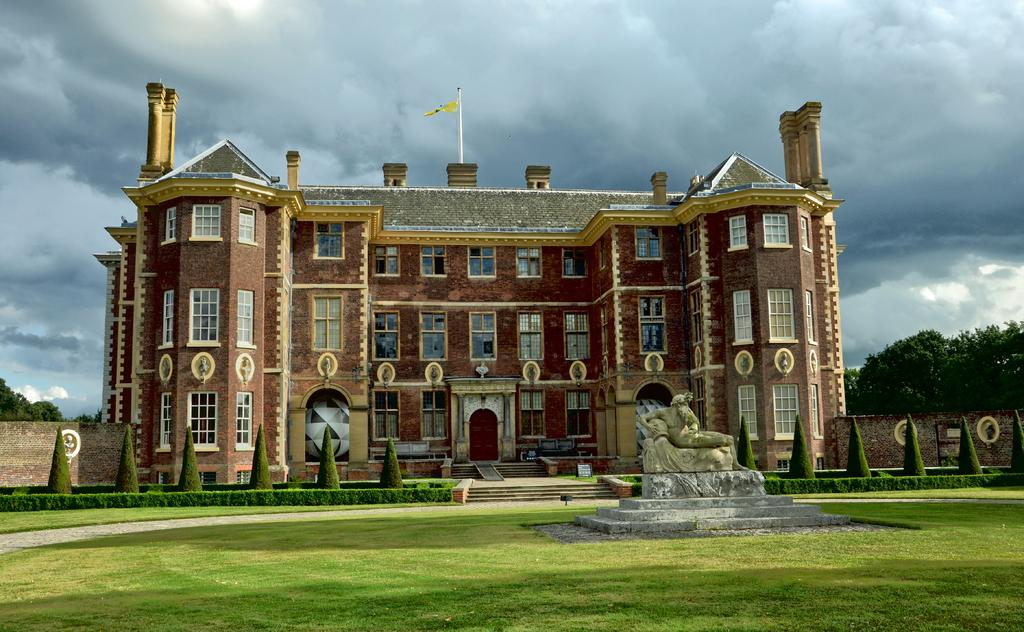What type of landscape is visible in the foreground of the image? There is grassland in the foreground of the image. What is located in the foreground of the image besides the grassland? There is a statue in the foreground of the image. What can be seen in the background of the image? There are trees, plants, a building, and a flag in the background of the image. What is visible at the top of the image? There are clouds visible at the top of the image. What type of plastic object is being used by the servant in the image? There is no servant or plastic object present in the image. How does the drop of water affect the grassland in the image? There is no mention of a drop of water in the image, so its effect on the grassland cannot be determined. 